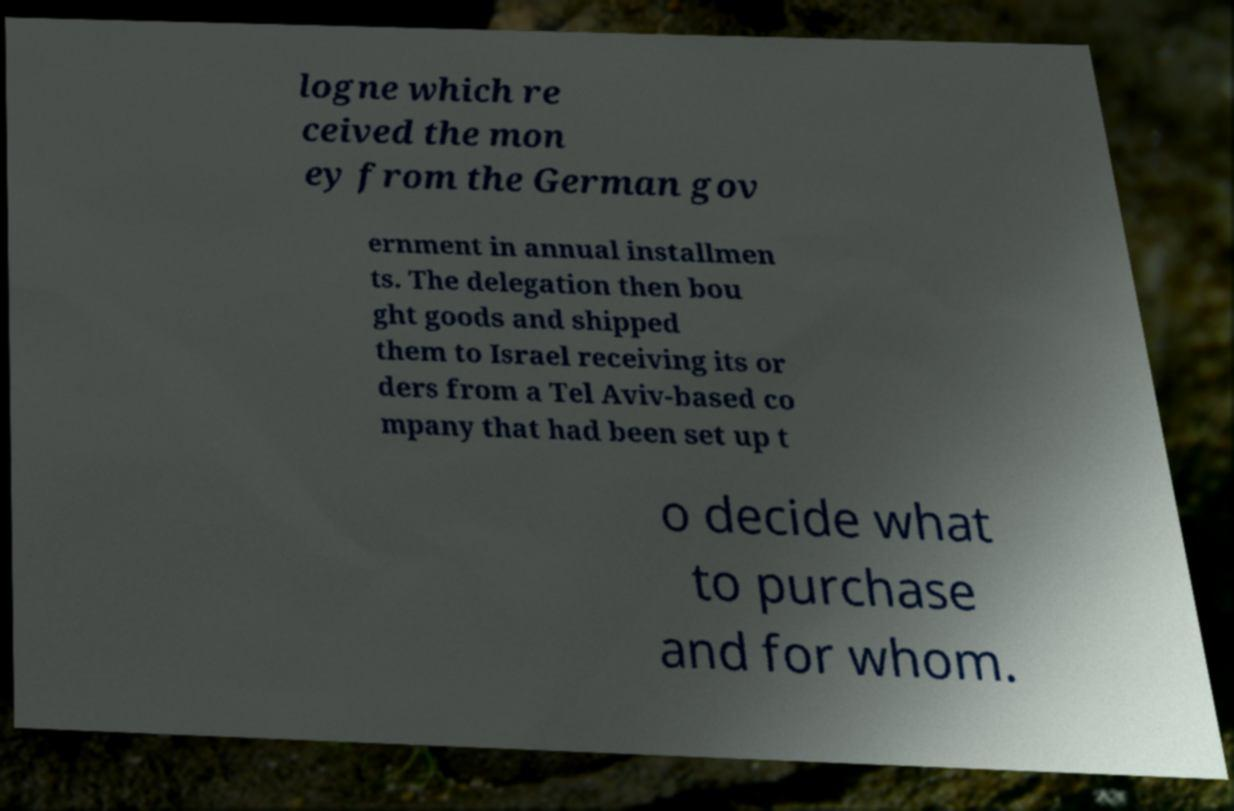What messages or text are displayed in this image? I need them in a readable, typed format. logne which re ceived the mon ey from the German gov ernment in annual installmen ts. The delegation then bou ght goods and shipped them to Israel receiving its or ders from a Tel Aviv-based co mpany that had been set up t o decide what to purchase and for whom. 